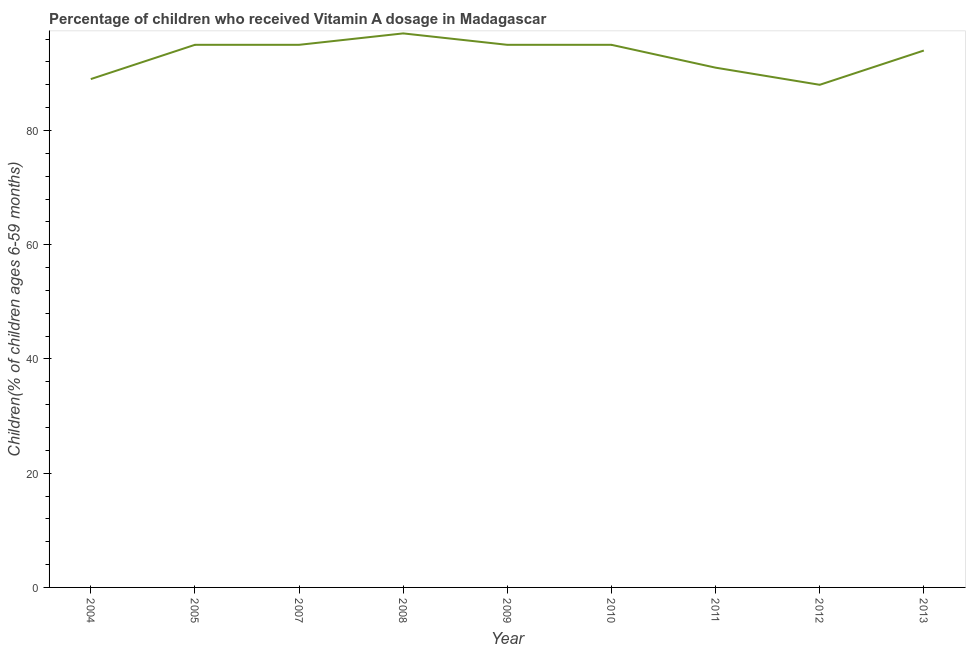What is the vitamin a supplementation coverage rate in 2004?
Your answer should be very brief. 89. Across all years, what is the maximum vitamin a supplementation coverage rate?
Offer a very short reply. 97. Across all years, what is the minimum vitamin a supplementation coverage rate?
Offer a very short reply. 88. What is the sum of the vitamin a supplementation coverage rate?
Give a very brief answer. 839. What is the difference between the vitamin a supplementation coverage rate in 2004 and 2009?
Give a very brief answer. -6. What is the average vitamin a supplementation coverage rate per year?
Give a very brief answer. 93.22. What is the median vitamin a supplementation coverage rate?
Give a very brief answer. 95. Do a majority of the years between 2004 and 2011 (inclusive) have vitamin a supplementation coverage rate greater than 16 %?
Give a very brief answer. Yes. What is the ratio of the vitamin a supplementation coverage rate in 2011 to that in 2013?
Your response must be concise. 0.97. Is the vitamin a supplementation coverage rate in 2007 less than that in 2013?
Ensure brevity in your answer.  No. Is the sum of the vitamin a supplementation coverage rate in 2005 and 2013 greater than the maximum vitamin a supplementation coverage rate across all years?
Your answer should be very brief. Yes. What is the difference between the highest and the lowest vitamin a supplementation coverage rate?
Offer a very short reply. 9. Does the vitamin a supplementation coverage rate monotonically increase over the years?
Give a very brief answer. No. Are the values on the major ticks of Y-axis written in scientific E-notation?
Keep it short and to the point. No. Does the graph contain grids?
Provide a short and direct response. No. What is the title of the graph?
Offer a very short reply. Percentage of children who received Vitamin A dosage in Madagascar. What is the label or title of the X-axis?
Make the answer very short. Year. What is the label or title of the Y-axis?
Make the answer very short. Children(% of children ages 6-59 months). What is the Children(% of children ages 6-59 months) in 2004?
Keep it short and to the point. 89. What is the Children(% of children ages 6-59 months) in 2005?
Give a very brief answer. 95. What is the Children(% of children ages 6-59 months) of 2008?
Offer a terse response. 97. What is the Children(% of children ages 6-59 months) of 2011?
Offer a very short reply. 91. What is the Children(% of children ages 6-59 months) in 2013?
Offer a very short reply. 94. What is the difference between the Children(% of children ages 6-59 months) in 2004 and 2007?
Make the answer very short. -6. What is the difference between the Children(% of children ages 6-59 months) in 2004 and 2008?
Your answer should be compact. -8. What is the difference between the Children(% of children ages 6-59 months) in 2004 and 2009?
Provide a succinct answer. -6. What is the difference between the Children(% of children ages 6-59 months) in 2004 and 2010?
Ensure brevity in your answer.  -6. What is the difference between the Children(% of children ages 6-59 months) in 2004 and 2012?
Make the answer very short. 1. What is the difference between the Children(% of children ages 6-59 months) in 2004 and 2013?
Provide a succinct answer. -5. What is the difference between the Children(% of children ages 6-59 months) in 2005 and 2007?
Keep it short and to the point. 0. What is the difference between the Children(% of children ages 6-59 months) in 2005 and 2009?
Your answer should be very brief. 0. What is the difference between the Children(% of children ages 6-59 months) in 2005 and 2012?
Keep it short and to the point. 7. What is the difference between the Children(% of children ages 6-59 months) in 2007 and 2008?
Your response must be concise. -2. What is the difference between the Children(% of children ages 6-59 months) in 2007 and 2009?
Give a very brief answer. 0. What is the difference between the Children(% of children ages 6-59 months) in 2007 and 2010?
Offer a terse response. 0. What is the difference between the Children(% of children ages 6-59 months) in 2007 and 2012?
Your response must be concise. 7. What is the difference between the Children(% of children ages 6-59 months) in 2008 and 2009?
Keep it short and to the point. 2. What is the difference between the Children(% of children ages 6-59 months) in 2008 and 2012?
Your answer should be very brief. 9. What is the difference between the Children(% of children ages 6-59 months) in 2008 and 2013?
Make the answer very short. 3. What is the difference between the Children(% of children ages 6-59 months) in 2009 and 2010?
Offer a terse response. 0. What is the difference between the Children(% of children ages 6-59 months) in 2009 and 2011?
Keep it short and to the point. 4. What is the difference between the Children(% of children ages 6-59 months) in 2009 and 2012?
Make the answer very short. 7. What is the difference between the Children(% of children ages 6-59 months) in 2010 and 2012?
Ensure brevity in your answer.  7. What is the difference between the Children(% of children ages 6-59 months) in 2011 and 2013?
Offer a terse response. -3. What is the ratio of the Children(% of children ages 6-59 months) in 2004 to that in 2005?
Give a very brief answer. 0.94. What is the ratio of the Children(% of children ages 6-59 months) in 2004 to that in 2007?
Provide a succinct answer. 0.94. What is the ratio of the Children(% of children ages 6-59 months) in 2004 to that in 2008?
Your answer should be very brief. 0.92. What is the ratio of the Children(% of children ages 6-59 months) in 2004 to that in 2009?
Offer a terse response. 0.94. What is the ratio of the Children(% of children ages 6-59 months) in 2004 to that in 2010?
Make the answer very short. 0.94. What is the ratio of the Children(% of children ages 6-59 months) in 2004 to that in 2012?
Make the answer very short. 1.01. What is the ratio of the Children(% of children ages 6-59 months) in 2004 to that in 2013?
Your answer should be compact. 0.95. What is the ratio of the Children(% of children ages 6-59 months) in 2005 to that in 2007?
Your answer should be very brief. 1. What is the ratio of the Children(% of children ages 6-59 months) in 2005 to that in 2009?
Ensure brevity in your answer.  1. What is the ratio of the Children(% of children ages 6-59 months) in 2005 to that in 2011?
Offer a very short reply. 1.04. What is the ratio of the Children(% of children ages 6-59 months) in 2007 to that in 2008?
Keep it short and to the point. 0.98. What is the ratio of the Children(% of children ages 6-59 months) in 2007 to that in 2009?
Provide a short and direct response. 1. What is the ratio of the Children(% of children ages 6-59 months) in 2007 to that in 2010?
Make the answer very short. 1. What is the ratio of the Children(% of children ages 6-59 months) in 2007 to that in 2011?
Ensure brevity in your answer.  1.04. What is the ratio of the Children(% of children ages 6-59 months) in 2008 to that in 2009?
Ensure brevity in your answer.  1.02. What is the ratio of the Children(% of children ages 6-59 months) in 2008 to that in 2011?
Offer a very short reply. 1.07. What is the ratio of the Children(% of children ages 6-59 months) in 2008 to that in 2012?
Provide a succinct answer. 1.1. What is the ratio of the Children(% of children ages 6-59 months) in 2008 to that in 2013?
Your response must be concise. 1.03. What is the ratio of the Children(% of children ages 6-59 months) in 2009 to that in 2011?
Keep it short and to the point. 1.04. What is the ratio of the Children(% of children ages 6-59 months) in 2009 to that in 2012?
Provide a short and direct response. 1.08. What is the ratio of the Children(% of children ages 6-59 months) in 2010 to that in 2011?
Provide a short and direct response. 1.04. What is the ratio of the Children(% of children ages 6-59 months) in 2010 to that in 2012?
Provide a succinct answer. 1.08. What is the ratio of the Children(% of children ages 6-59 months) in 2010 to that in 2013?
Your answer should be compact. 1.01. What is the ratio of the Children(% of children ages 6-59 months) in 2011 to that in 2012?
Keep it short and to the point. 1.03. What is the ratio of the Children(% of children ages 6-59 months) in 2012 to that in 2013?
Offer a terse response. 0.94. 